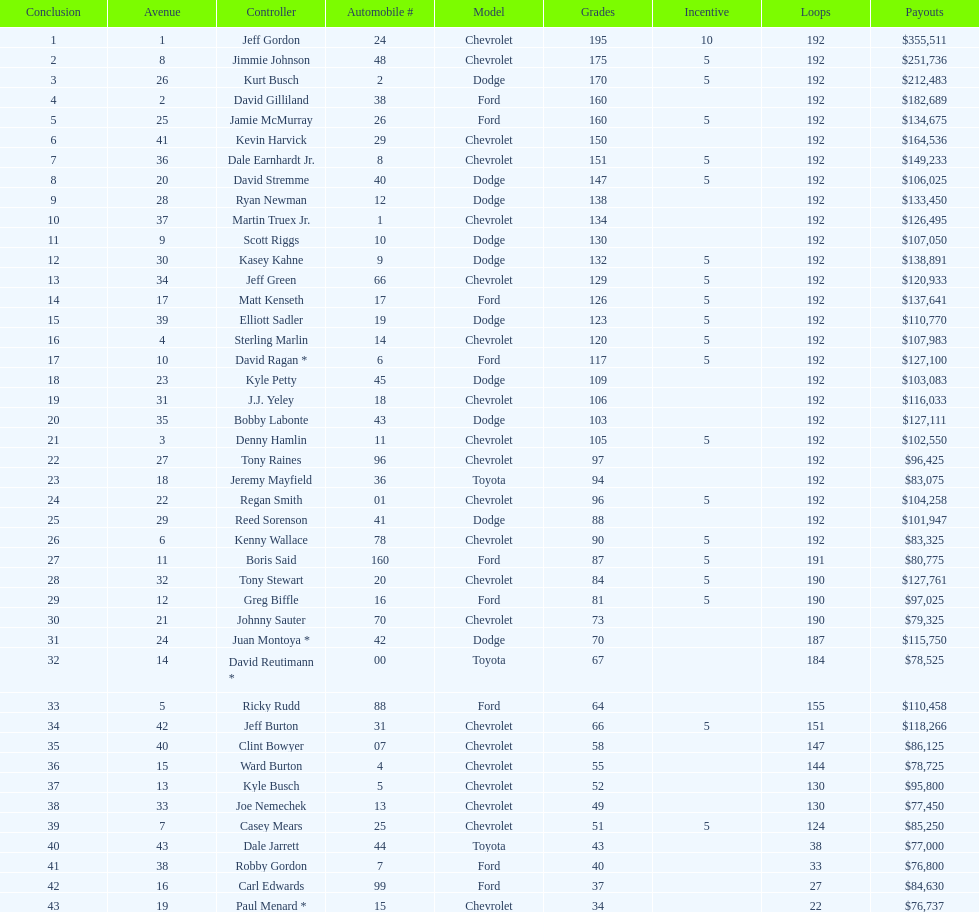How many drivers placed below tony stewart? 15. 